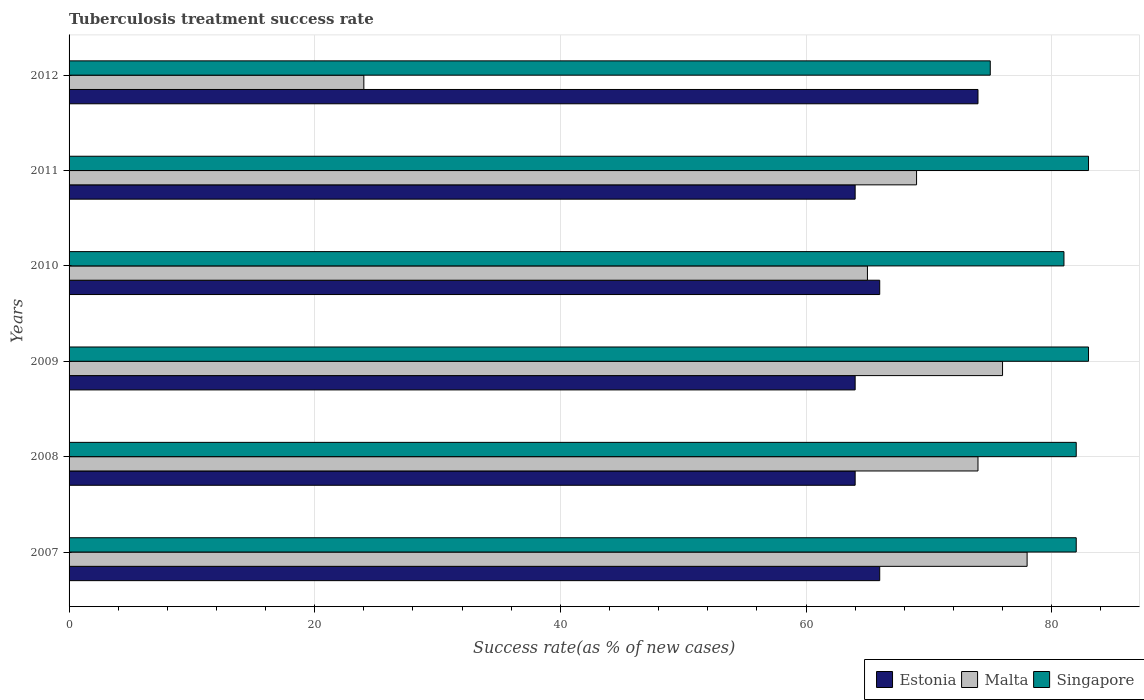How many groups of bars are there?
Provide a succinct answer. 6. In how many cases, is the number of bars for a given year not equal to the number of legend labels?
Provide a short and direct response. 0. What is the tuberculosis treatment success rate in Singapore in 2010?
Offer a very short reply. 81. Across all years, what is the maximum tuberculosis treatment success rate in Malta?
Your response must be concise. 78. Across all years, what is the minimum tuberculosis treatment success rate in Malta?
Offer a very short reply. 24. In which year was the tuberculosis treatment success rate in Singapore minimum?
Provide a succinct answer. 2012. What is the total tuberculosis treatment success rate in Singapore in the graph?
Your response must be concise. 486. What is the average tuberculosis treatment success rate in Singapore per year?
Your response must be concise. 81. In how many years, is the tuberculosis treatment success rate in Estonia greater than 12 %?
Ensure brevity in your answer.  6. What is the ratio of the tuberculosis treatment success rate in Malta in 2008 to that in 2010?
Offer a terse response. 1.14. Is the difference between the tuberculosis treatment success rate in Malta in 2007 and 2011 greater than the difference between the tuberculosis treatment success rate in Estonia in 2007 and 2011?
Provide a succinct answer. Yes. What is the difference between the highest and the lowest tuberculosis treatment success rate in Malta?
Give a very brief answer. 54. What does the 2nd bar from the top in 2009 represents?
Offer a terse response. Malta. What does the 1st bar from the bottom in 2008 represents?
Give a very brief answer. Estonia. Is it the case that in every year, the sum of the tuberculosis treatment success rate in Singapore and tuberculosis treatment success rate in Malta is greater than the tuberculosis treatment success rate in Estonia?
Ensure brevity in your answer.  Yes. How many bars are there?
Provide a succinct answer. 18. Are all the bars in the graph horizontal?
Provide a short and direct response. Yes. Are the values on the major ticks of X-axis written in scientific E-notation?
Give a very brief answer. No. Does the graph contain any zero values?
Your response must be concise. No. How many legend labels are there?
Give a very brief answer. 3. How are the legend labels stacked?
Your response must be concise. Horizontal. What is the title of the graph?
Your answer should be compact. Tuberculosis treatment success rate. Does "Lesotho" appear as one of the legend labels in the graph?
Give a very brief answer. No. What is the label or title of the X-axis?
Make the answer very short. Success rate(as % of new cases). What is the label or title of the Y-axis?
Your answer should be very brief. Years. What is the Success rate(as % of new cases) of Estonia in 2007?
Your answer should be compact. 66. What is the Success rate(as % of new cases) of Singapore in 2007?
Offer a terse response. 82. What is the Success rate(as % of new cases) of Estonia in 2009?
Provide a succinct answer. 64. What is the Success rate(as % of new cases) in Malta in 2009?
Provide a short and direct response. 76. What is the Success rate(as % of new cases) in Singapore in 2009?
Make the answer very short. 83. What is the Success rate(as % of new cases) in Singapore in 2010?
Provide a short and direct response. 81. What is the Success rate(as % of new cases) in Singapore in 2011?
Your response must be concise. 83. What is the Success rate(as % of new cases) in Singapore in 2012?
Your answer should be very brief. 75. Across all years, what is the maximum Success rate(as % of new cases) of Estonia?
Ensure brevity in your answer.  74. Across all years, what is the maximum Success rate(as % of new cases) in Singapore?
Your answer should be compact. 83. Across all years, what is the minimum Success rate(as % of new cases) in Estonia?
Your answer should be compact. 64. Across all years, what is the minimum Success rate(as % of new cases) of Singapore?
Provide a short and direct response. 75. What is the total Success rate(as % of new cases) of Estonia in the graph?
Make the answer very short. 398. What is the total Success rate(as % of new cases) of Malta in the graph?
Your response must be concise. 386. What is the total Success rate(as % of new cases) in Singapore in the graph?
Your response must be concise. 486. What is the difference between the Success rate(as % of new cases) of Malta in 2007 and that in 2009?
Keep it short and to the point. 2. What is the difference between the Success rate(as % of new cases) of Malta in 2007 and that in 2011?
Your response must be concise. 9. What is the difference between the Success rate(as % of new cases) of Malta in 2008 and that in 2009?
Your response must be concise. -2. What is the difference between the Success rate(as % of new cases) of Singapore in 2008 and that in 2009?
Provide a succinct answer. -1. What is the difference between the Success rate(as % of new cases) in Malta in 2008 and that in 2010?
Your response must be concise. 9. What is the difference between the Success rate(as % of new cases) in Singapore in 2008 and that in 2010?
Offer a terse response. 1. What is the difference between the Success rate(as % of new cases) in Malta in 2008 and that in 2011?
Keep it short and to the point. 5. What is the difference between the Success rate(as % of new cases) of Malta in 2008 and that in 2012?
Keep it short and to the point. 50. What is the difference between the Success rate(as % of new cases) in Singapore in 2008 and that in 2012?
Offer a terse response. 7. What is the difference between the Success rate(as % of new cases) in Estonia in 2009 and that in 2010?
Give a very brief answer. -2. What is the difference between the Success rate(as % of new cases) in Malta in 2009 and that in 2010?
Offer a terse response. 11. What is the difference between the Success rate(as % of new cases) in Estonia in 2009 and that in 2011?
Offer a terse response. 0. What is the difference between the Success rate(as % of new cases) of Malta in 2009 and that in 2012?
Offer a very short reply. 52. What is the difference between the Success rate(as % of new cases) of Estonia in 2010 and that in 2011?
Your answer should be very brief. 2. What is the difference between the Success rate(as % of new cases) of Singapore in 2010 and that in 2011?
Offer a very short reply. -2. What is the difference between the Success rate(as % of new cases) of Estonia in 2010 and that in 2012?
Make the answer very short. -8. What is the difference between the Success rate(as % of new cases) in Singapore in 2010 and that in 2012?
Offer a terse response. 6. What is the difference between the Success rate(as % of new cases) of Malta in 2011 and that in 2012?
Give a very brief answer. 45. What is the difference between the Success rate(as % of new cases) in Estonia in 2007 and the Success rate(as % of new cases) in Singapore in 2008?
Provide a succinct answer. -16. What is the difference between the Success rate(as % of new cases) of Malta in 2007 and the Success rate(as % of new cases) of Singapore in 2008?
Your response must be concise. -4. What is the difference between the Success rate(as % of new cases) of Estonia in 2007 and the Success rate(as % of new cases) of Singapore in 2010?
Provide a succinct answer. -15. What is the difference between the Success rate(as % of new cases) in Malta in 2007 and the Success rate(as % of new cases) in Singapore in 2010?
Your response must be concise. -3. What is the difference between the Success rate(as % of new cases) in Estonia in 2007 and the Success rate(as % of new cases) in Singapore in 2011?
Offer a very short reply. -17. What is the difference between the Success rate(as % of new cases) of Estonia in 2007 and the Success rate(as % of new cases) of Malta in 2012?
Offer a very short reply. 42. What is the difference between the Success rate(as % of new cases) in Estonia in 2008 and the Success rate(as % of new cases) in Malta in 2009?
Ensure brevity in your answer.  -12. What is the difference between the Success rate(as % of new cases) in Estonia in 2008 and the Success rate(as % of new cases) in Singapore in 2009?
Provide a succinct answer. -19. What is the difference between the Success rate(as % of new cases) of Malta in 2008 and the Success rate(as % of new cases) of Singapore in 2009?
Provide a succinct answer. -9. What is the difference between the Success rate(as % of new cases) in Estonia in 2008 and the Success rate(as % of new cases) in Malta in 2010?
Provide a succinct answer. -1. What is the difference between the Success rate(as % of new cases) of Estonia in 2008 and the Success rate(as % of new cases) of Singapore in 2010?
Give a very brief answer. -17. What is the difference between the Success rate(as % of new cases) of Estonia in 2008 and the Success rate(as % of new cases) of Malta in 2011?
Provide a succinct answer. -5. What is the difference between the Success rate(as % of new cases) of Malta in 2008 and the Success rate(as % of new cases) of Singapore in 2011?
Give a very brief answer. -9. What is the difference between the Success rate(as % of new cases) in Estonia in 2008 and the Success rate(as % of new cases) in Singapore in 2012?
Keep it short and to the point. -11. What is the difference between the Success rate(as % of new cases) in Malta in 2008 and the Success rate(as % of new cases) in Singapore in 2012?
Make the answer very short. -1. What is the difference between the Success rate(as % of new cases) in Estonia in 2009 and the Success rate(as % of new cases) in Singapore in 2010?
Keep it short and to the point. -17. What is the difference between the Success rate(as % of new cases) of Malta in 2009 and the Success rate(as % of new cases) of Singapore in 2010?
Offer a very short reply. -5. What is the difference between the Success rate(as % of new cases) of Malta in 2009 and the Success rate(as % of new cases) of Singapore in 2011?
Provide a short and direct response. -7. What is the difference between the Success rate(as % of new cases) in Estonia in 2009 and the Success rate(as % of new cases) in Malta in 2012?
Ensure brevity in your answer.  40. What is the difference between the Success rate(as % of new cases) in Estonia in 2009 and the Success rate(as % of new cases) in Singapore in 2012?
Offer a very short reply. -11. What is the difference between the Success rate(as % of new cases) of Estonia in 2010 and the Success rate(as % of new cases) of Malta in 2011?
Your answer should be compact. -3. What is the difference between the Success rate(as % of new cases) of Estonia in 2010 and the Success rate(as % of new cases) of Singapore in 2011?
Keep it short and to the point. -17. What is the difference between the Success rate(as % of new cases) of Estonia in 2010 and the Success rate(as % of new cases) of Malta in 2012?
Keep it short and to the point. 42. What is the difference between the Success rate(as % of new cases) in Estonia in 2010 and the Success rate(as % of new cases) in Singapore in 2012?
Give a very brief answer. -9. What is the difference between the Success rate(as % of new cases) in Malta in 2010 and the Success rate(as % of new cases) in Singapore in 2012?
Offer a terse response. -10. What is the difference between the Success rate(as % of new cases) in Estonia in 2011 and the Success rate(as % of new cases) in Malta in 2012?
Your answer should be very brief. 40. What is the difference between the Success rate(as % of new cases) in Estonia in 2011 and the Success rate(as % of new cases) in Singapore in 2012?
Offer a terse response. -11. What is the difference between the Success rate(as % of new cases) in Malta in 2011 and the Success rate(as % of new cases) in Singapore in 2012?
Make the answer very short. -6. What is the average Success rate(as % of new cases) in Estonia per year?
Your response must be concise. 66.33. What is the average Success rate(as % of new cases) in Malta per year?
Keep it short and to the point. 64.33. In the year 2007, what is the difference between the Success rate(as % of new cases) of Estonia and Success rate(as % of new cases) of Malta?
Your response must be concise. -12. In the year 2008, what is the difference between the Success rate(as % of new cases) of Estonia and Success rate(as % of new cases) of Malta?
Ensure brevity in your answer.  -10. In the year 2008, what is the difference between the Success rate(as % of new cases) of Malta and Success rate(as % of new cases) of Singapore?
Ensure brevity in your answer.  -8. In the year 2009, what is the difference between the Success rate(as % of new cases) of Estonia and Success rate(as % of new cases) of Malta?
Offer a very short reply. -12. In the year 2009, what is the difference between the Success rate(as % of new cases) in Estonia and Success rate(as % of new cases) in Singapore?
Make the answer very short. -19. In the year 2010, what is the difference between the Success rate(as % of new cases) in Estonia and Success rate(as % of new cases) in Malta?
Keep it short and to the point. 1. In the year 2011, what is the difference between the Success rate(as % of new cases) of Estonia and Success rate(as % of new cases) of Malta?
Offer a very short reply. -5. In the year 2011, what is the difference between the Success rate(as % of new cases) of Estonia and Success rate(as % of new cases) of Singapore?
Keep it short and to the point. -19. In the year 2012, what is the difference between the Success rate(as % of new cases) of Estonia and Success rate(as % of new cases) of Malta?
Offer a terse response. 50. In the year 2012, what is the difference between the Success rate(as % of new cases) in Malta and Success rate(as % of new cases) in Singapore?
Your answer should be compact. -51. What is the ratio of the Success rate(as % of new cases) of Estonia in 2007 to that in 2008?
Provide a short and direct response. 1.03. What is the ratio of the Success rate(as % of new cases) of Malta in 2007 to that in 2008?
Offer a very short reply. 1.05. What is the ratio of the Success rate(as % of new cases) in Estonia in 2007 to that in 2009?
Provide a succinct answer. 1.03. What is the ratio of the Success rate(as % of new cases) of Malta in 2007 to that in 2009?
Offer a very short reply. 1.03. What is the ratio of the Success rate(as % of new cases) in Malta in 2007 to that in 2010?
Ensure brevity in your answer.  1.2. What is the ratio of the Success rate(as % of new cases) in Singapore in 2007 to that in 2010?
Make the answer very short. 1.01. What is the ratio of the Success rate(as % of new cases) of Estonia in 2007 to that in 2011?
Keep it short and to the point. 1.03. What is the ratio of the Success rate(as % of new cases) of Malta in 2007 to that in 2011?
Your answer should be compact. 1.13. What is the ratio of the Success rate(as % of new cases) of Singapore in 2007 to that in 2011?
Provide a short and direct response. 0.99. What is the ratio of the Success rate(as % of new cases) of Estonia in 2007 to that in 2012?
Your response must be concise. 0.89. What is the ratio of the Success rate(as % of new cases) of Malta in 2007 to that in 2012?
Make the answer very short. 3.25. What is the ratio of the Success rate(as % of new cases) of Singapore in 2007 to that in 2012?
Keep it short and to the point. 1.09. What is the ratio of the Success rate(as % of new cases) in Malta in 2008 to that in 2009?
Make the answer very short. 0.97. What is the ratio of the Success rate(as % of new cases) in Estonia in 2008 to that in 2010?
Your response must be concise. 0.97. What is the ratio of the Success rate(as % of new cases) in Malta in 2008 to that in 2010?
Provide a short and direct response. 1.14. What is the ratio of the Success rate(as % of new cases) in Singapore in 2008 to that in 2010?
Provide a succinct answer. 1.01. What is the ratio of the Success rate(as % of new cases) in Estonia in 2008 to that in 2011?
Your response must be concise. 1. What is the ratio of the Success rate(as % of new cases) of Malta in 2008 to that in 2011?
Your answer should be compact. 1.07. What is the ratio of the Success rate(as % of new cases) of Estonia in 2008 to that in 2012?
Ensure brevity in your answer.  0.86. What is the ratio of the Success rate(as % of new cases) in Malta in 2008 to that in 2012?
Your response must be concise. 3.08. What is the ratio of the Success rate(as % of new cases) in Singapore in 2008 to that in 2012?
Your answer should be compact. 1.09. What is the ratio of the Success rate(as % of new cases) of Estonia in 2009 to that in 2010?
Give a very brief answer. 0.97. What is the ratio of the Success rate(as % of new cases) in Malta in 2009 to that in 2010?
Provide a succinct answer. 1.17. What is the ratio of the Success rate(as % of new cases) in Singapore in 2009 to that in 2010?
Give a very brief answer. 1.02. What is the ratio of the Success rate(as % of new cases) in Estonia in 2009 to that in 2011?
Make the answer very short. 1. What is the ratio of the Success rate(as % of new cases) of Malta in 2009 to that in 2011?
Your answer should be compact. 1.1. What is the ratio of the Success rate(as % of new cases) in Singapore in 2009 to that in 2011?
Keep it short and to the point. 1. What is the ratio of the Success rate(as % of new cases) of Estonia in 2009 to that in 2012?
Provide a short and direct response. 0.86. What is the ratio of the Success rate(as % of new cases) in Malta in 2009 to that in 2012?
Provide a succinct answer. 3.17. What is the ratio of the Success rate(as % of new cases) in Singapore in 2009 to that in 2012?
Your response must be concise. 1.11. What is the ratio of the Success rate(as % of new cases) of Estonia in 2010 to that in 2011?
Your answer should be very brief. 1.03. What is the ratio of the Success rate(as % of new cases) in Malta in 2010 to that in 2011?
Provide a succinct answer. 0.94. What is the ratio of the Success rate(as % of new cases) in Singapore in 2010 to that in 2011?
Ensure brevity in your answer.  0.98. What is the ratio of the Success rate(as % of new cases) of Estonia in 2010 to that in 2012?
Give a very brief answer. 0.89. What is the ratio of the Success rate(as % of new cases) of Malta in 2010 to that in 2012?
Offer a terse response. 2.71. What is the ratio of the Success rate(as % of new cases) in Estonia in 2011 to that in 2012?
Provide a short and direct response. 0.86. What is the ratio of the Success rate(as % of new cases) of Malta in 2011 to that in 2012?
Your response must be concise. 2.88. What is the ratio of the Success rate(as % of new cases) in Singapore in 2011 to that in 2012?
Your response must be concise. 1.11. What is the difference between the highest and the second highest Success rate(as % of new cases) in Estonia?
Give a very brief answer. 8. What is the difference between the highest and the second highest Success rate(as % of new cases) in Singapore?
Offer a terse response. 0. What is the difference between the highest and the lowest Success rate(as % of new cases) of Malta?
Provide a short and direct response. 54. 